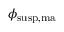Convert formula to latex. <formula><loc_0><loc_0><loc_500><loc_500>\phi _ { s u s p , m a }</formula> 